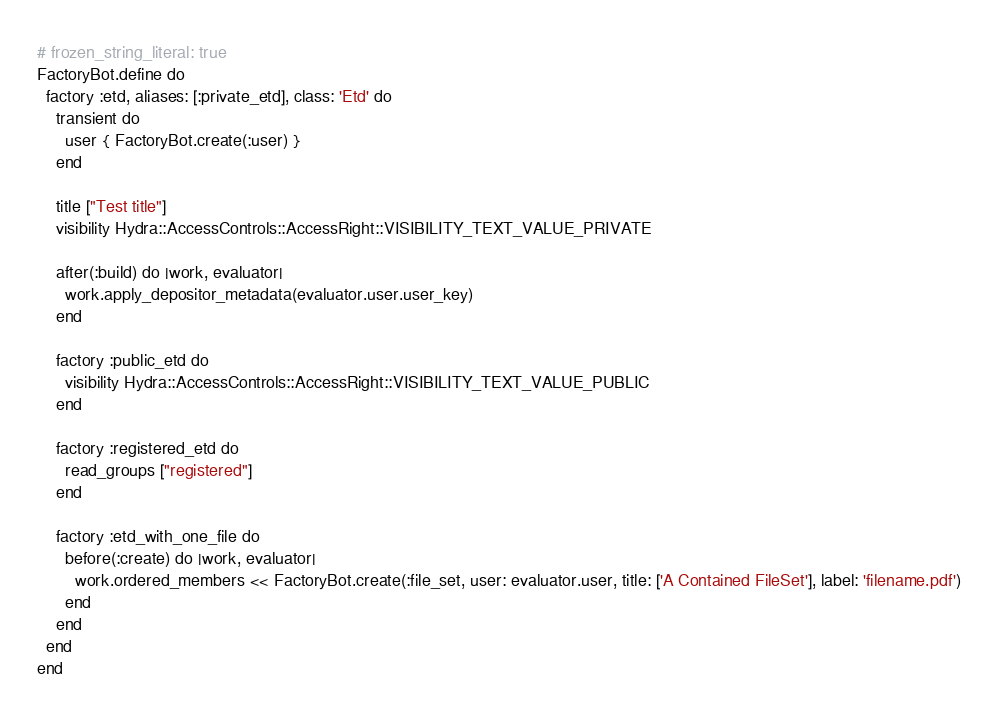<code> <loc_0><loc_0><loc_500><loc_500><_Ruby_># frozen_string_literal: true
FactoryBot.define do
  factory :etd, aliases: [:private_etd], class: 'Etd' do
    transient do
      user { FactoryBot.create(:user) }
    end

    title ["Test title"]
    visibility Hydra::AccessControls::AccessRight::VISIBILITY_TEXT_VALUE_PRIVATE

    after(:build) do |work, evaluator|
      work.apply_depositor_metadata(evaluator.user.user_key)
    end

    factory :public_etd do
      visibility Hydra::AccessControls::AccessRight::VISIBILITY_TEXT_VALUE_PUBLIC
    end

    factory :registered_etd do
      read_groups ["registered"]
    end

    factory :etd_with_one_file do
      before(:create) do |work, evaluator|
        work.ordered_members << FactoryBot.create(:file_set, user: evaluator.user, title: ['A Contained FileSet'], label: 'filename.pdf')
      end
    end
  end
end
</code> 